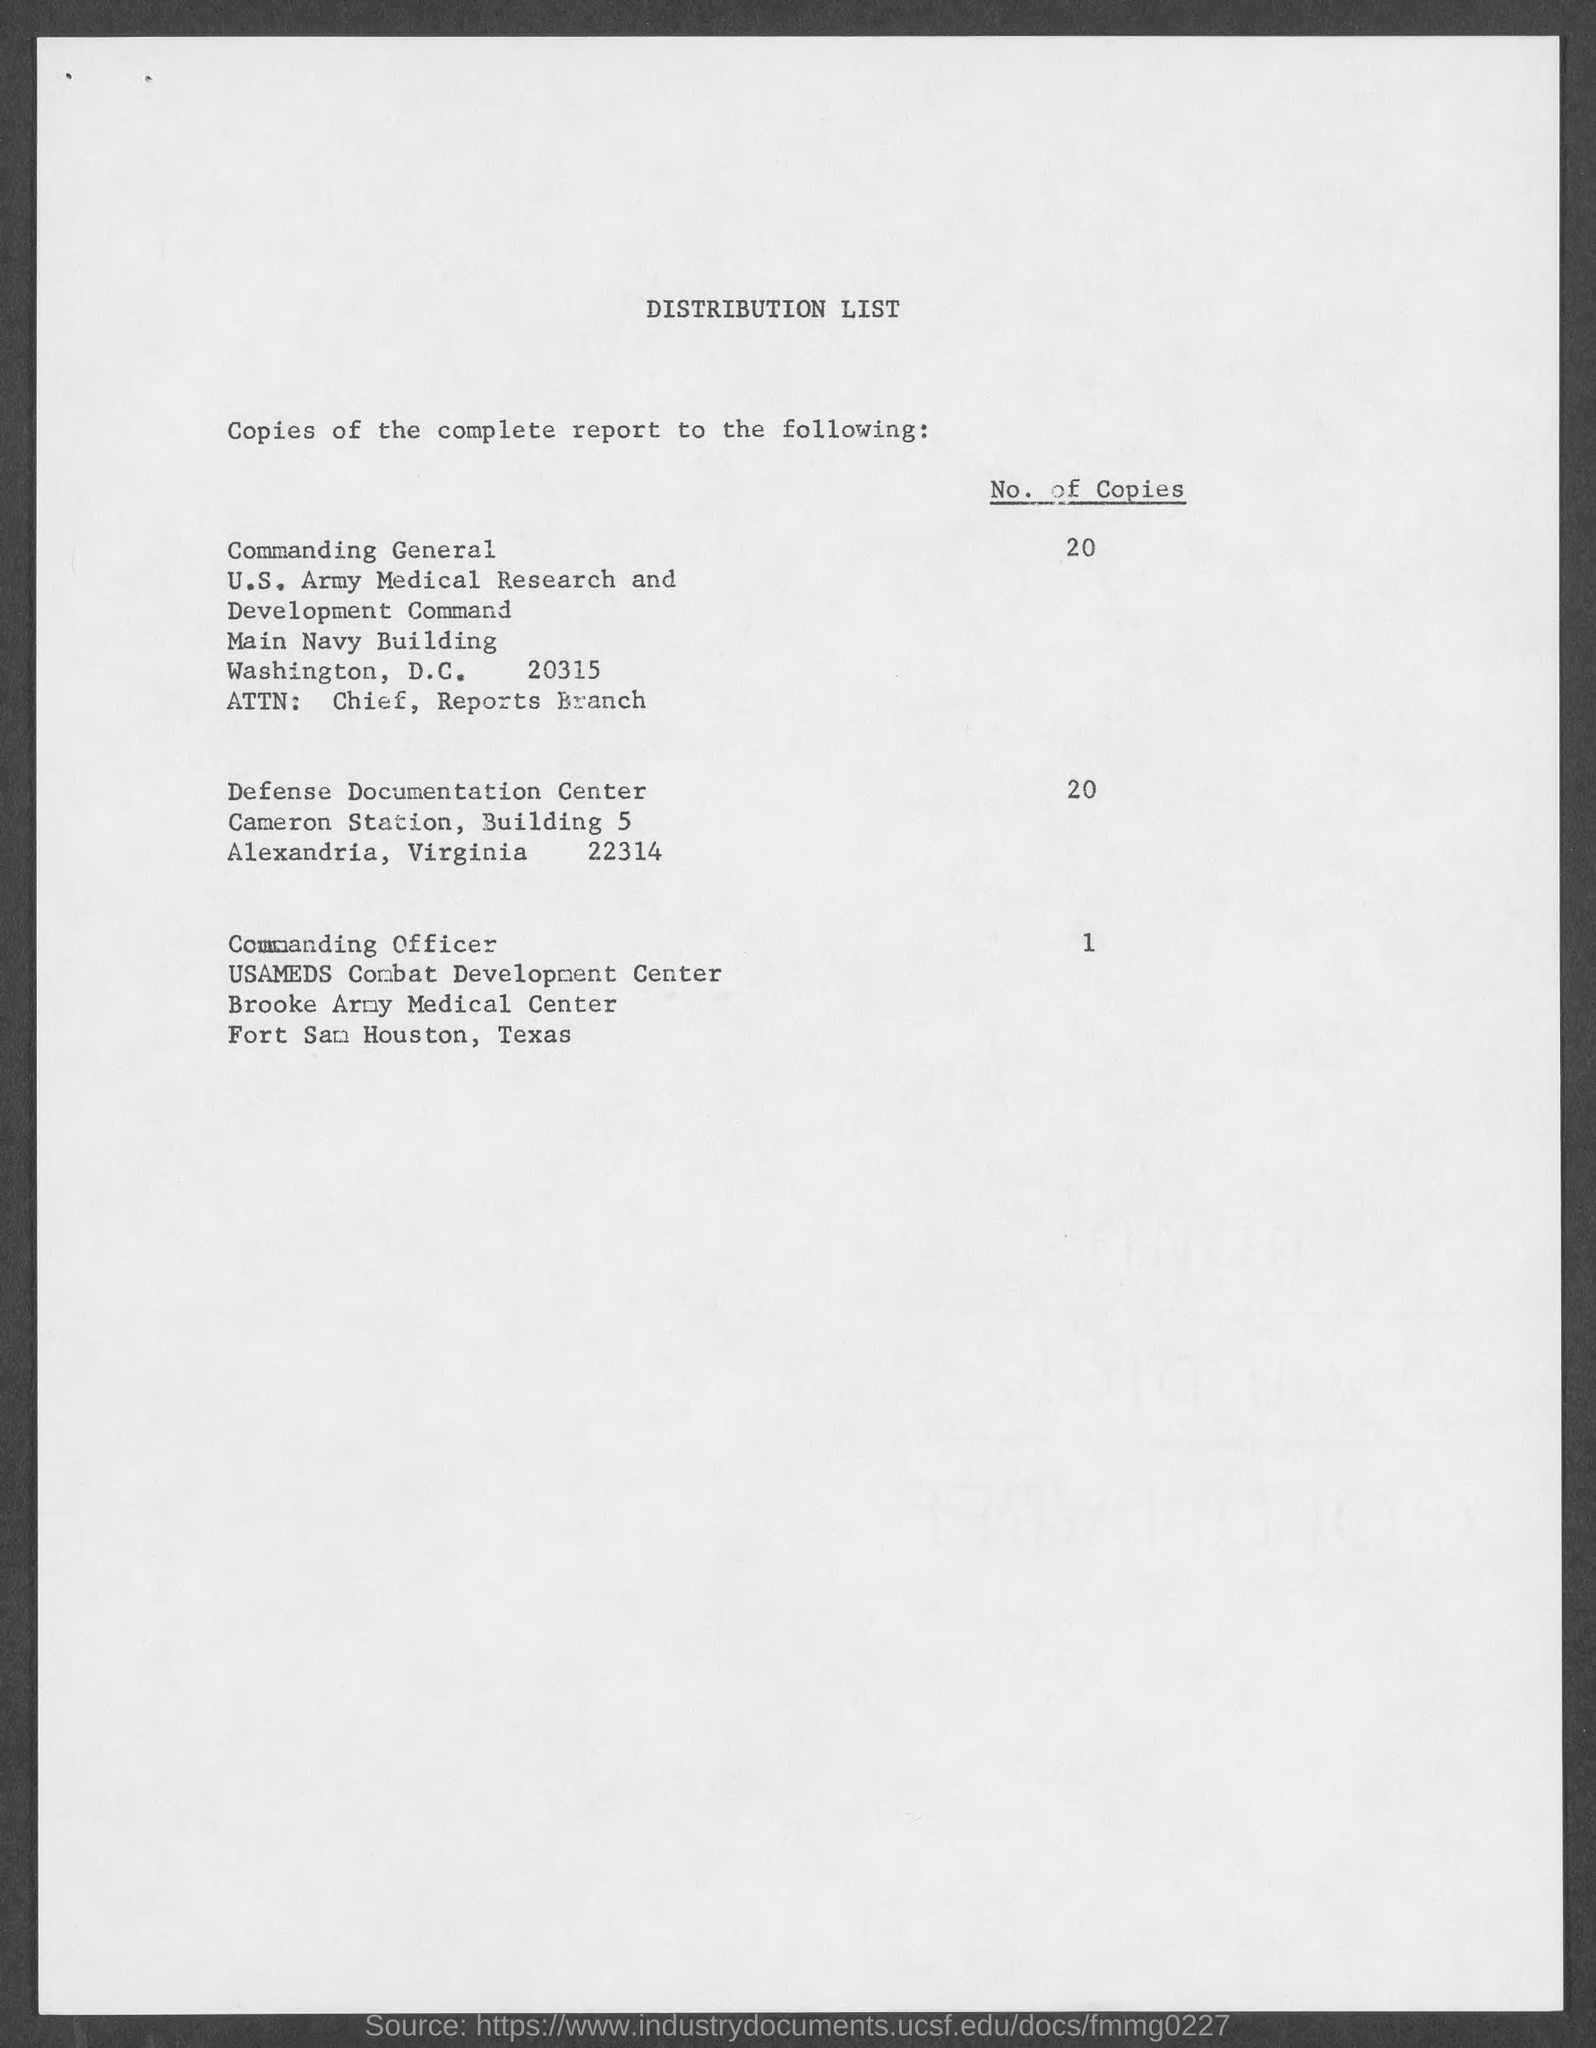what is the no. of copies for Commanding officer? The Commanding Officer at Brooke Army Medical Center is allocated 1 copy, as stated in the distribution list under the 'Commanding Officer' entry. 